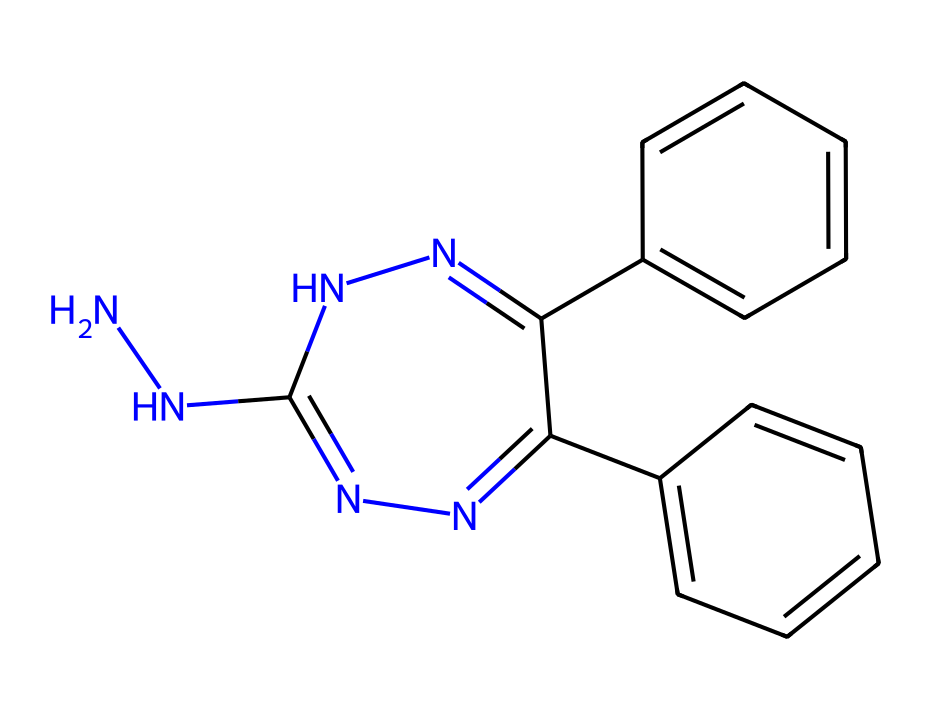What is the molecular formula of hydralazine? To determine the molecular formula, you can count the number of each type of atom in the SMILES representation. There are 10 carbon atoms (C), 12 hydrogen atoms (H), 4 nitrogen atoms (N), leading to the formula C10H12N4.
Answer: C10H12N4 How many rings are present in the structure? By analyzing the structure, you can identify the rings by looking for cyclic components. There are two distinct rings found in the molecule.
Answer: 2 What is the main functional group in hydralazine? The presence of two nitrogen atoms connected by single bonds, along with the carbon atoms, indicates that the molecule contains hydrazine as its primary functional group.
Answer: hydrazine What is the total number of nitrogen atoms in hydralazine? By scanning the SMILES representation for nitrogen (N) symbols, you can count four nitrogen atoms present in the structure.
Answer: 4 What type of isomerism can occur in hydralazine? The molecule has chiral centers, leading to possible stereoisomerism. Since there are configurations around certain carbon atoms, it can exhibit geometric isomerism with different spatial arrangements.
Answer: stereoisomerism 